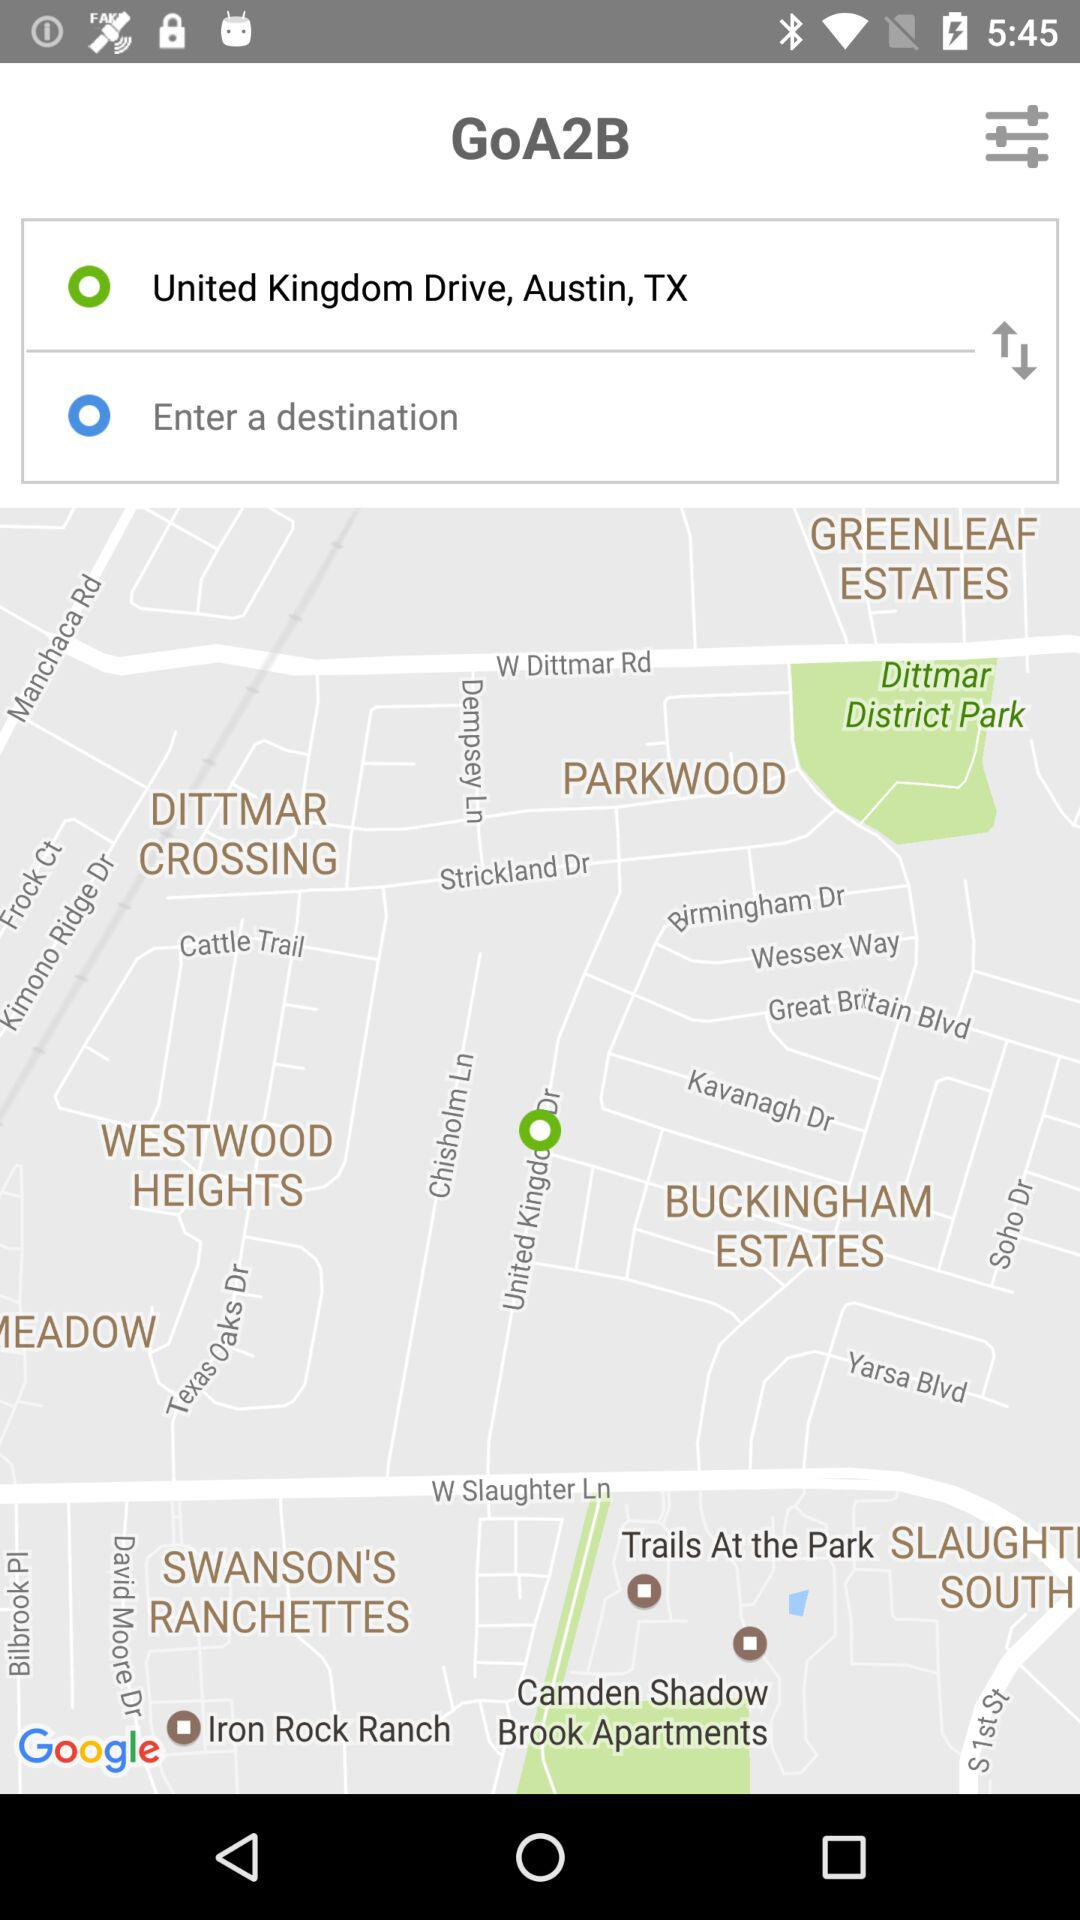How many more green circles are there than blue circles?
Answer the question using a single word or phrase. 1 